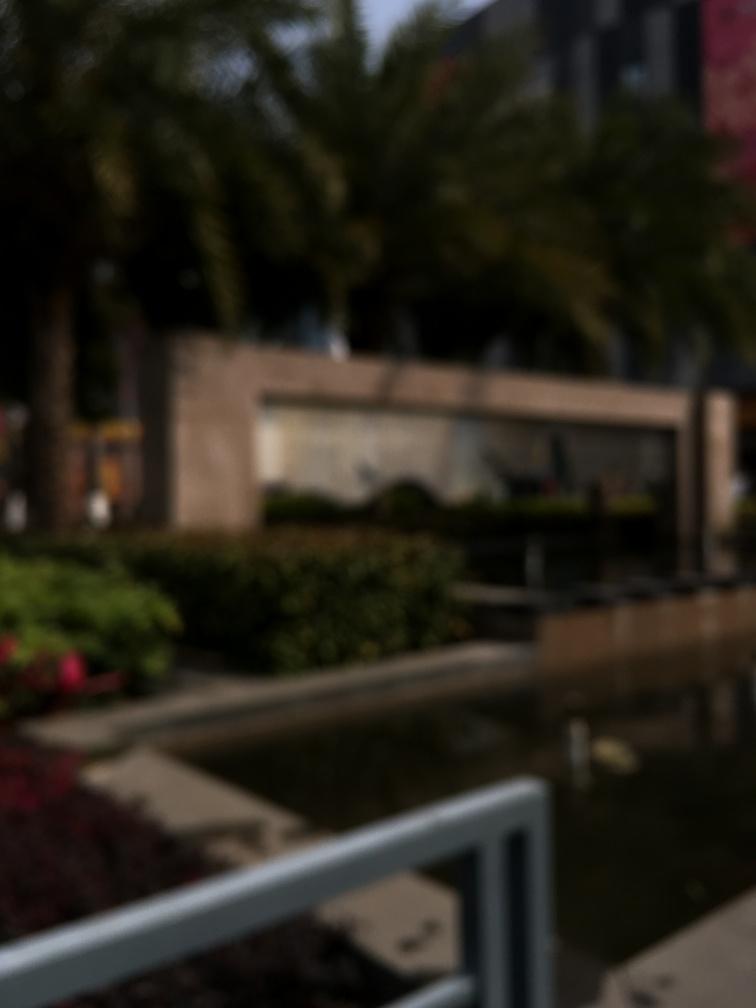Can you describe what might be the subject of this image despite the blurriness? While the image is blurry, it appears to capture an outdoor scene, potentially an urban park or a landscaped area, featuring what might be trees, a bench, and a water feature or fountain. 